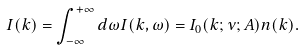Convert formula to latex. <formula><loc_0><loc_0><loc_500><loc_500>I ( k ) = \int _ { - \infty } ^ { + \infty } d \omega I ( k , \omega ) = I _ { 0 } ( { k } ; \nu ; { A } ) n ( { k } ) .</formula> 